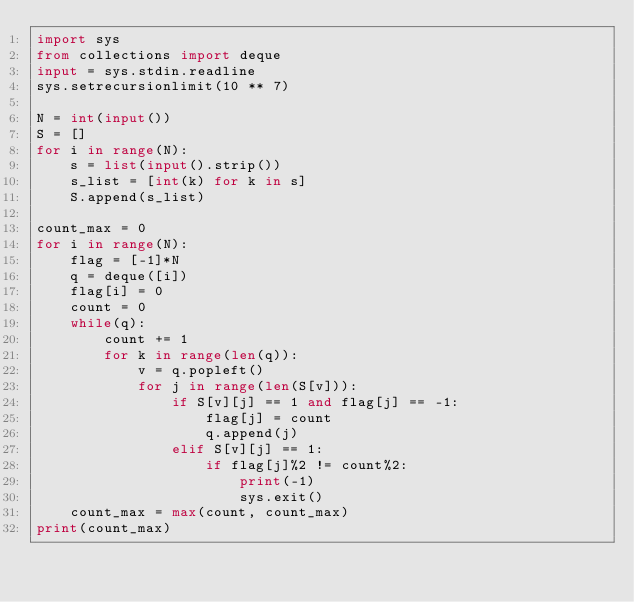<code> <loc_0><loc_0><loc_500><loc_500><_Python_>import sys
from collections import deque
input = sys.stdin.readline
sys.setrecursionlimit(10 ** 7)

N = int(input())
S = []
for i in range(N):
    s = list(input().strip())
    s_list = [int(k) for k in s]
    S.append(s_list)

count_max = 0
for i in range(N):
    flag = [-1]*N
    q = deque([i])
    flag[i] = 0
    count = 0
    while(q):
        count += 1
        for k in range(len(q)):
            v = q.popleft()
            for j in range(len(S[v])):
                if S[v][j] == 1 and flag[j] == -1:
                    flag[j] = count
                    q.append(j)
                elif S[v][j] == 1:
                    if flag[j]%2 != count%2:
                        print(-1)
                        sys.exit()
    count_max = max(count, count_max)
print(count_max)
        
</code> 